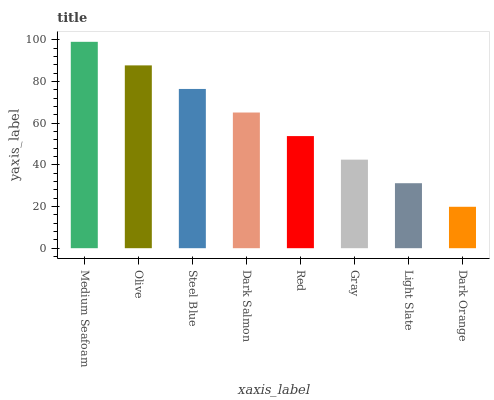Is Dark Orange the minimum?
Answer yes or no. Yes. Is Medium Seafoam the maximum?
Answer yes or no. Yes. Is Olive the minimum?
Answer yes or no. No. Is Olive the maximum?
Answer yes or no. No. Is Medium Seafoam greater than Olive?
Answer yes or no. Yes. Is Olive less than Medium Seafoam?
Answer yes or no. Yes. Is Olive greater than Medium Seafoam?
Answer yes or no. No. Is Medium Seafoam less than Olive?
Answer yes or no. No. Is Dark Salmon the high median?
Answer yes or no. Yes. Is Red the low median?
Answer yes or no. Yes. Is Red the high median?
Answer yes or no. No. Is Steel Blue the low median?
Answer yes or no. No. 